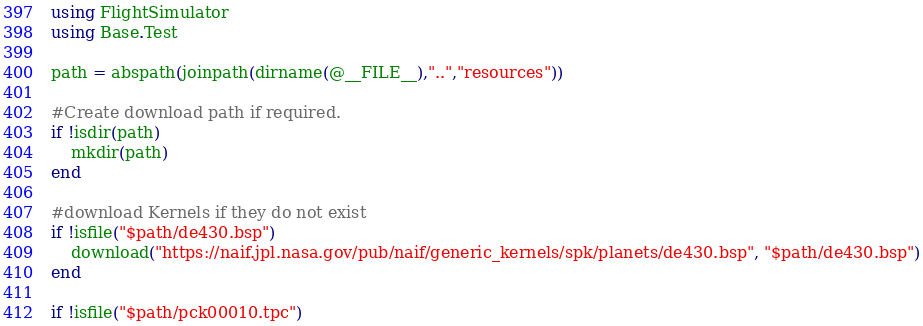<code> <loc_0><loc_0><loc_500><loc_500><_Julia_>using FlightSimulator
using Base.Test 

path = abspath(joinpath(dirname(@__FILE__),"..","resources"))

#Create download path if required. 
if !isdir(path)
    mkdir(path)
end 

#download Kernels if they do not exist
if !isfile("$path/de430.bsp")
    download("https://naif.jpl.nasa.gov/pub/naif/generic_kernels/spk/planets/de430.bsp", "$path/de430.bsp")
end 

if !isfile("$path/pck00010.tpc")</code> 